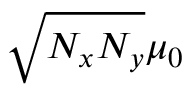<formula> <loc_0><loc_0><loc_500><loc_500>\sqrt { N _ { x } N _ { y } } \mu _ { 0 }</formula> 